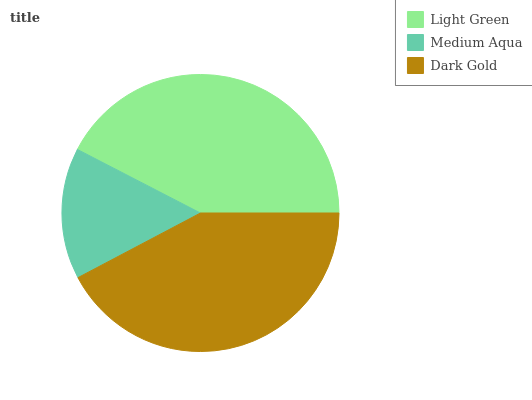Is Medium Aqua the minimum?
Answer yes or no. Yes. Is Light Green the maximum?
Answer yes or no. Yes. Is Dark Gold the minimum?
Answer yes or no. No. Is Dark Gold the maximum?
Answer yes or no. No. Is Dark Gold greater than Medium Aqua?
Answer yes or no. Yes. Is Medium Aqua less than Dark Gold?
Answer yes or no. Yes. Is Medium Aqua greater than Dark Gold?
Answer yes or no. No. Is Dark Gold less than Medium Aqua?
Answer yes or no. No. Is Dark Gold the high median?
Answer yes or no. Yes. Is Dark Gold the low median?
Answer yes or no. Yes. Is Medium Aqua the high median?
Answer yes or no. No. Is Light Green the low median?
Answer yes or no. No. 